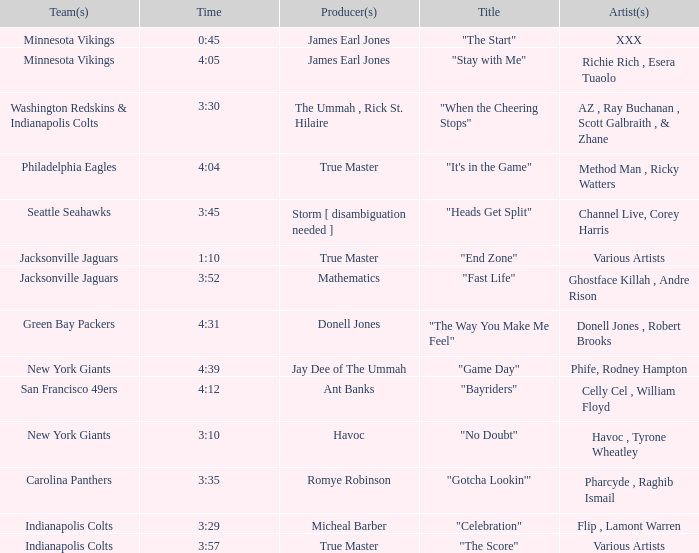Which artist is responsible for the new york giants' song "no doubt"? Havoc , Tyrone Wheatley. 